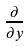Convert formula to latex. <formula><loc_0><loc_0><loc_500><loc_500>\frac { \partial } { \partial y }</formula> 